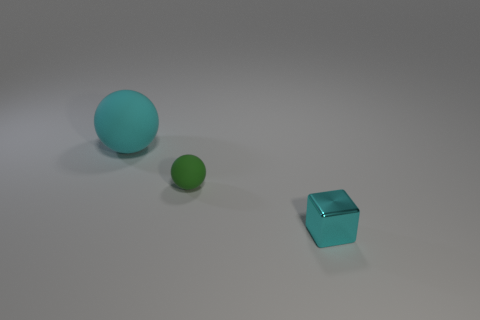What shape is the tiny object that is the same color as the large rubber object?
Give a very brief answer. Cube. What is the shape of the cyan thing that is to the right of the big cyan sphere?
Ensure brevity in your answer.  Cube. There is a cyan object that is on the left side of the shiny object; is its shape the same as the tiny matte thing?
Your answer should be very brief. Yes. How many objects are either matte balls that are to the right of the large ball or purple blocks?
Provide a succinct answer. 1. What is the color of the other small matte thing that is the same shape as the cyan matte object?
Offer a very short reply. Green. Is there anything else of the same color as the small cube?
Give a very brief answer. Yes. There is a matte sphere that is in front of the big cyan matte ball; what size is it?
Provide a short and direct response. Small. Is the color of the tiny block the same as the matte sphere in front of the cyan ball?
Keep it short and to the point. No. How many other things are there of the same material as the large object?
Your response must be concise. 1. Are there more cyan cubes than tiny yellow metal cylinders?
Offer a very short reply. Yes. 